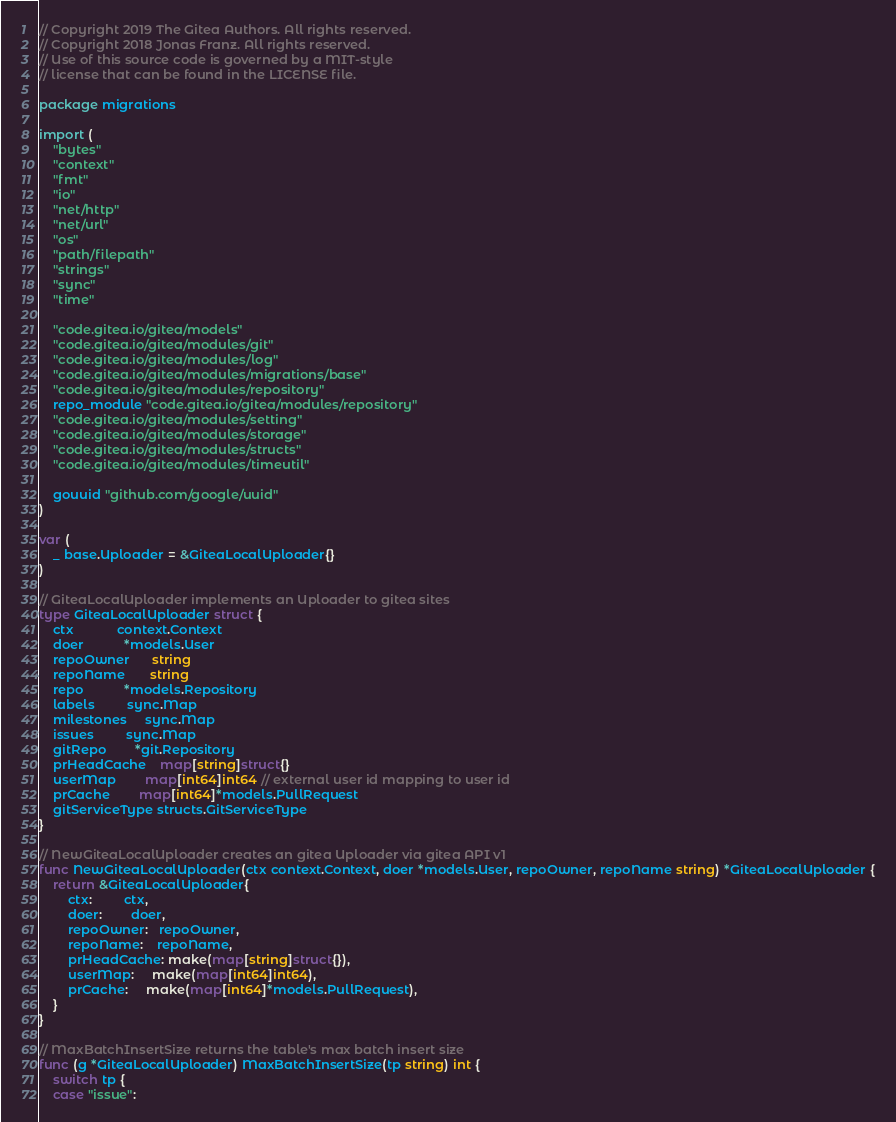Convert code to text. <code><loc_0><loc_0><loc_500><loc_500><_Go_>// Copyright 2019 The Gitea Authors. All rights reserved.
// Copyright 2018 Jonas Franz. All rights reserved.
// Use of this source code is governed by a MIT-style
// license that can be found in the LICENSE file.

package migrations

import (
	"bytes"
	"context"
	"fmt"
	"io"
	"net/http"
	"net/url"
	"os"
	"path/filepath"
	"strings"
	"sync"
	"time"

	"code.gitea.io/gitea/models"
	"code.gitea.io/gitea/modules/git"
	"code.gitea.io/gitea/modules/log"
	"code.gitea.io/gitea/modules/migrations/base"
	"code.gitea.io/gitea/modules/repository"
	repo_module "code.gitea.io/gitea/modules/repository"
	"code.gitea.io/gitea/modules/setting"
	"code.gitea.io/gitea/modules/storage"
	"code.gitea.io/gitea/modules/structs"
	"code.gitea.io/gitea/modules/timeutil"

	gouuid "github.com/google/uuid"
)

var (
	_ base.Uploader = &GiteaLocalUploader{}
)

// GiteaLocalUploader implements an Uploader to gitea sites
type GiteaLocalUploader struct {
	ctx            context.Context
	doer           *models.User
	repoOwner      string
	repoName       string
	repo           *models.Repository
	labels         sync.Map
	milestones     sync.Map
	issues         sync.Map
	gitRepo        *git.Repository
	prHeadCache    map[string]struct{}
	userMap        map[int64]int64 // external user id mapping to user id
	prCache        map[int64]*models.PullRequest
	gitServiceType structs.GitServiceType
}

// NewGiteaLocalUploader creates an gitea Uploader via gitea API v1
func NewGiteaLocalUploader(ctx context.Context, doer *models.User, repoOwner, repoName string) *GiteaLocalUploader {
	return &GiteaLocalUploader{
		ctx:         ctx,
		doer:        doer,
		repoOwner:   repoOwner,
		repoName:    repoName,
		prHeadCache: make(map[string]struct{}),
		userMap:     make(map[int64]int64),
		prCache:     make(map[int64]*models.PullRequest),
	}
}

// MaxBatchInsertSize returns the table's max batch insert size
func (g *GiteaLocalUploader) MaxBatchInsertSize(tp string) int {
	switch tp {
	case "issue":</code> 